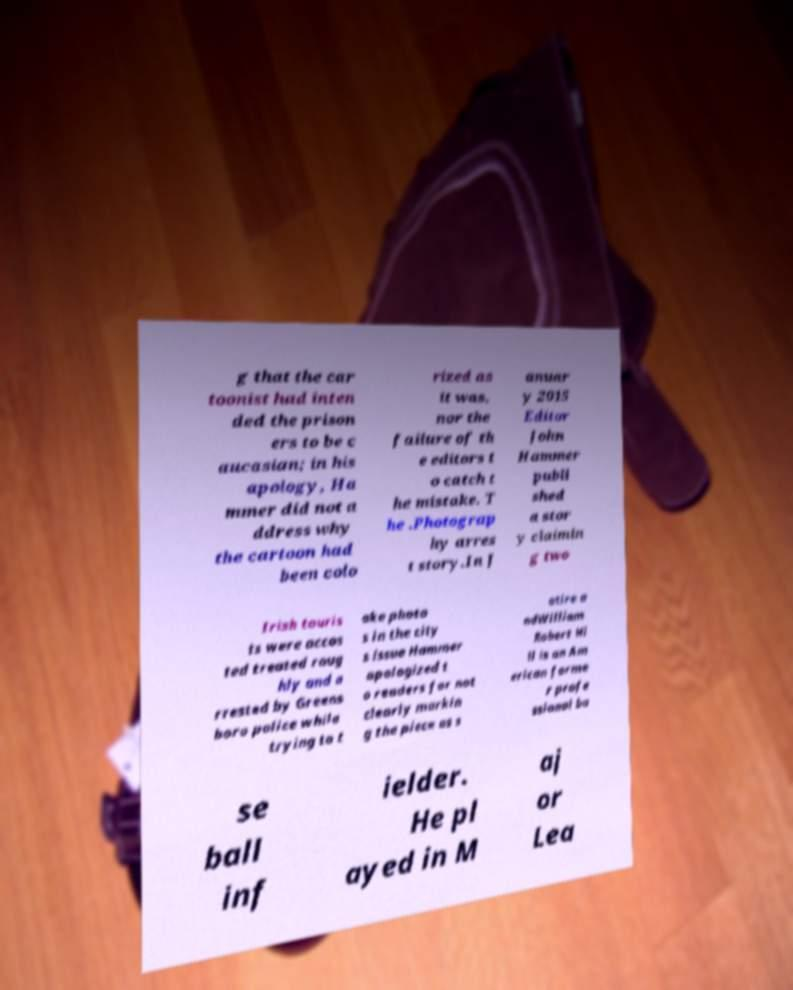Could you assist in decoding the text presented in this image and type it out clearly? g that the car toonist had inten ded the prison ers to be c aucasian; in his apology, Ha mmer did not a ddress why the cartoon had been colo rized as it was, nor the failure of th e editors t o catch t he mistake. T he .Photograp hy arres t story.In J anuar y 2015 Editor John Hammer publi shed a stor y claimin g two Irish touris ts were accos ted treated roug hly and a rrested by Greens boro police while trying to t ake photo s in the city s issue Hammer apologized t o readers for not clearly markin g the piece as s atire a ndWilliam Robert Hi ll is an Am erican forme r profe ssional ba se ball inf ielder. He pl ayed in M aj or Lea 